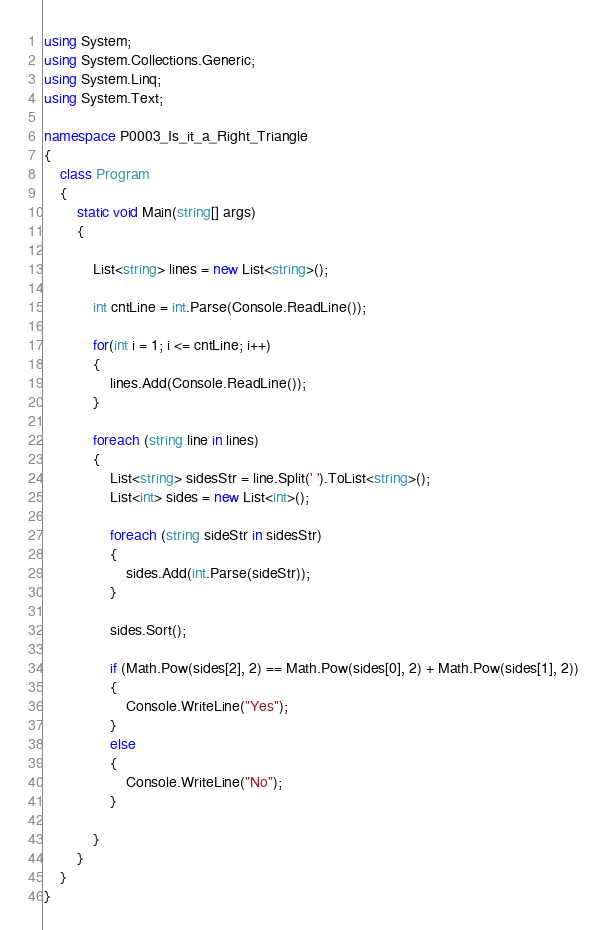Convert code to text. <code><loc_0><loc_0><loc_500><loc_500><_C#_>using System;
using System.Collections.Generic;
using System.Linq;
using System.Text;

namespace P0003_Is_it_a_Right_Triangle
{
    class Program
    {
        static void Main(string[] args)
        {

            List<string> lines = new List<string>();

            int cntLine = int.Parse(Console.ReadLine());

            for(int i = 1; i <= cntLine; i++)
            {
                lines.Add(Console.ReadLine());
            }          

            foreach (string line in lines)
            {
                List<string> sidesStr = line.Split(' ').ToList<string>();
                List<int> sides = new List<int>();

                foreach (string sideStr in sidesStr)
                {
                    sides.Add(int.Parse(sideStr));
                }

                sides.Sort();

                if (Math.Pow(sides[2], 2) == Math.Pow(sides[0], 2) + Math.Pow(sides[1], 2))
                {
                    Console.WriteLine("Yes");
                }
                else
                {
                    Console.WriteLine("No");
                }

            }
        }
    }
}</code> 